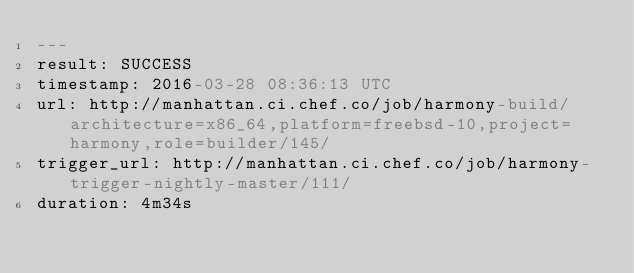Convert code to text. <code><loc_0><loc_0><loc_500><loc_500><_YAML_>---
result: SUCCESS
timestamp: 2016-03-28 08:36:13 UTC
url: http://manhattan.ci.chef.co/job/harmony-build/architecture=x86_64,platform=freebsd-10,project=harmony,role=builder/145/
trigger_url: http://manhattan.ci.chef.co/job/harmony-trigger-nightly-master/111/
duration: 4m34s
</code> 